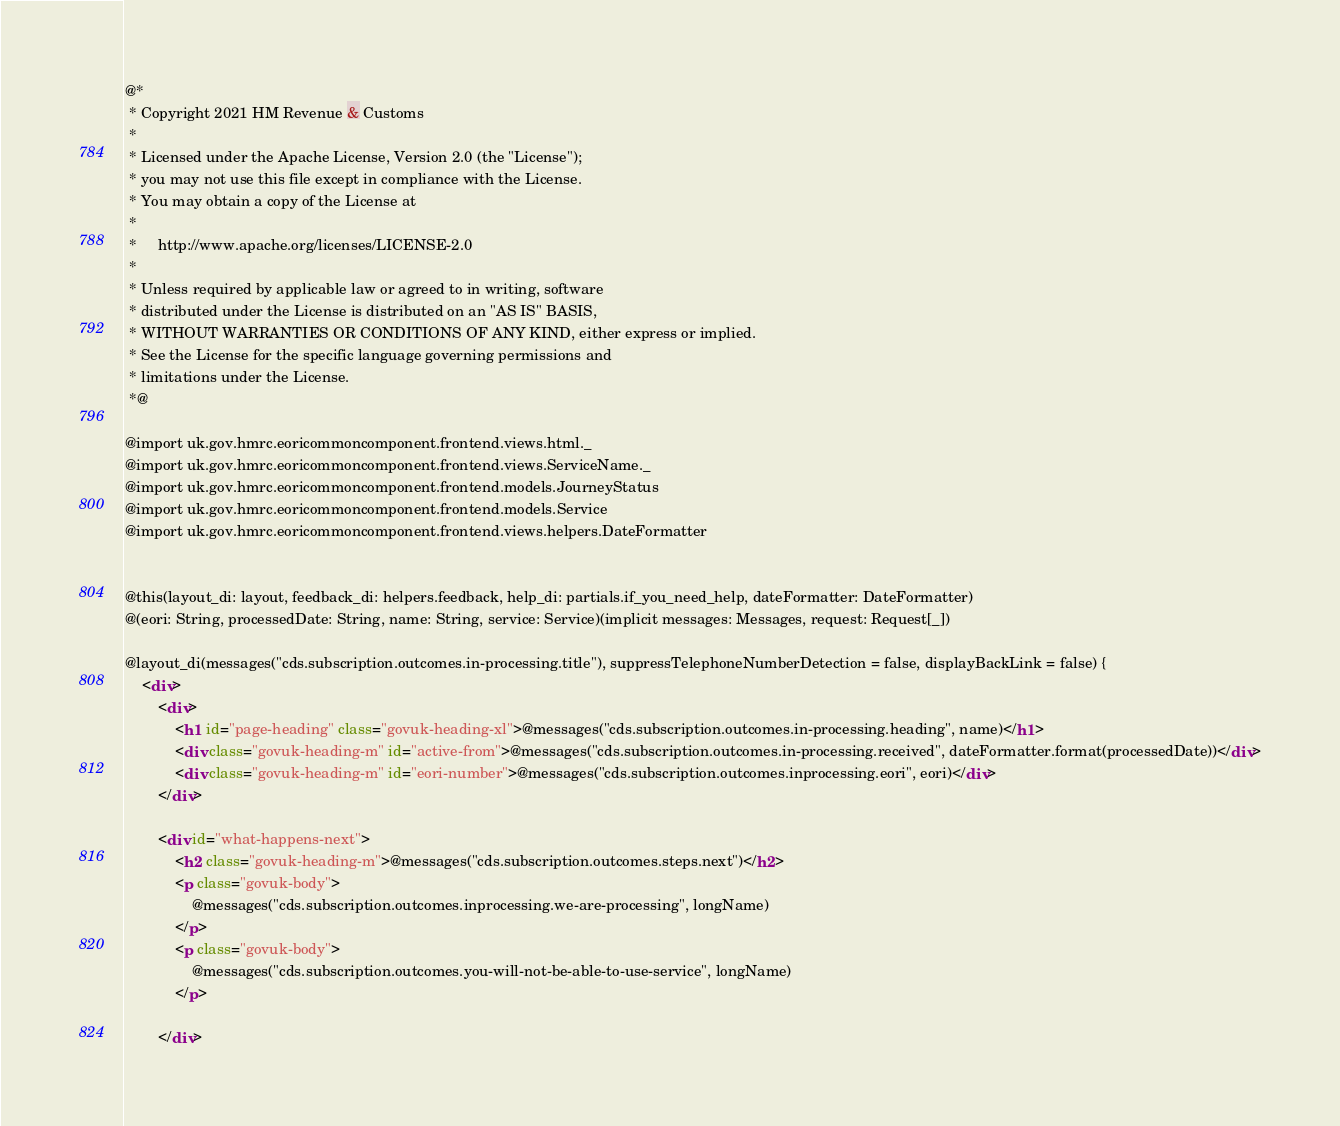<code> <loc_0><loc_0><loc_500><loc_500><_HTML_>@*
 * Copyright 2021 HM Revenue & Customs
 *
 * Licensed under the Apache License, Version 2.0 (the "License");
 * you may not use this file except in compliance with the License.
 * You may obtain a copy of the License at
 *
 *     http://www.apache.org/licenses/LICENSE-2.0
 *
 * Unless required by applicable law or agreed to in writing, software
 * distributed under the License is distributed on an "AS IS" BASIS,
 * WITHOUT WARRANTIES OR CONDITIONS OF ANY KIND, either express or implied.
 * See the License for the specific language governing permissions and
 * limitations under the License.
 *@

@import uk.gov.hmrc.eoricommoncomponent.frontend.views.html._
@import uk.gov.hmrc.eoricommoncomponent.frontend.views.ServiceName._
@import uk.gov.hmrc.eoricommoncomponent.frontend.models.JourneyStatus
@import uk.gov.hmrc.eoricommoncomponent.frontend.models.Service
@import uk.gov.hmrc.eoricommoncomponent.frontend.views.helpers.DateFormatter


@this(layout_di: layout, feedback_di: helpers.feedback, help_di: partials.if_you_need_help, dateFormatter: DateFormatter)
@(eori: String, processedDate: String, name: String, service: Service)(implicit messages: Messages, request: Request[_])

@layout_di(messages("cds.subscription.outcomes.in-processing.title"), suppressTelephoneNumberDetection = false, displayBackLink = false) {
    <div>
        <div>
            <h1 id="page-heading" class="govuk-heading-xl">@messages("cds.subscription.outcomes.in-processing.heading", name)</h1>
            <div class="govuk-heading-m" id="active-from">@messages("cds.subscription.outcomes.in-processing.received", dateFormatter.format(processedDate))</div>
            <div class="govuk-heading-m" id="eori-number">@messages("cds.subscription.outcomes.inprocessing.eori", eori)</div>
        </div>

        <div id="what-happens-next">
            <h2 class="govuk-heading-m">@messages("cds.subscription.outcomes.steps.next")</h2>
            <p class="govuk-body">
                @messages("cds.subscription.outcomes.inprocessing.we-are-processing", longName)
            </p>
            <p class="govuk-body">
                @messages("cds.subscription.outcomes.you-will-not-be-able-to-use-service", longName)
            </p>

        </div>
</code> 